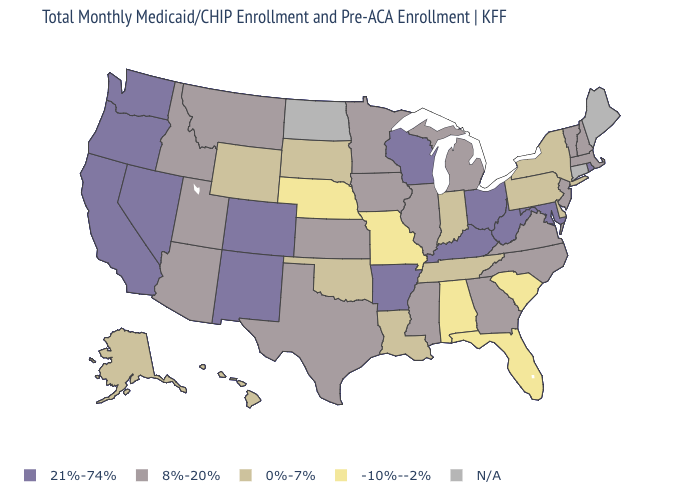What is the value of Illinois?
Short answer required. 8%-20%. Does the map have missing data?
Write a very short answer. Yes. What is the value of Utah?
Short answer required. 8%-20%. Among the states that border Connecticut , which have the lowest value?
Give a very brief answer. New York. Among the states that border Texas , which have the highest value?
Short answer required. Arkansas, New Mexico. Is the legend a continuous bar?
Be succinct. No. Name the states that have a value in the range 0%-7%?
Give a very brief answer. Alaska, Delaware, Hawaii, Indiana, Louisiana, New York, Oklahoma, Pennsylvania, South Dakota, Tennessee, Wyoming. What is the highest value in the South ?
Quick response, please. 21%-74%. What is the highest value in states that border Kentucky?
Give a very brief answer. 21%-74%. Among the states that border Oklahoma , does Arkansas have the lowest value?
Write a very short answer. No. Among the states that border Tennessee , which have the lowest value?
Quick response, please. Alabama, Missouri. What is the value of Wyoming?
Answer briefly. 0%-7%. 